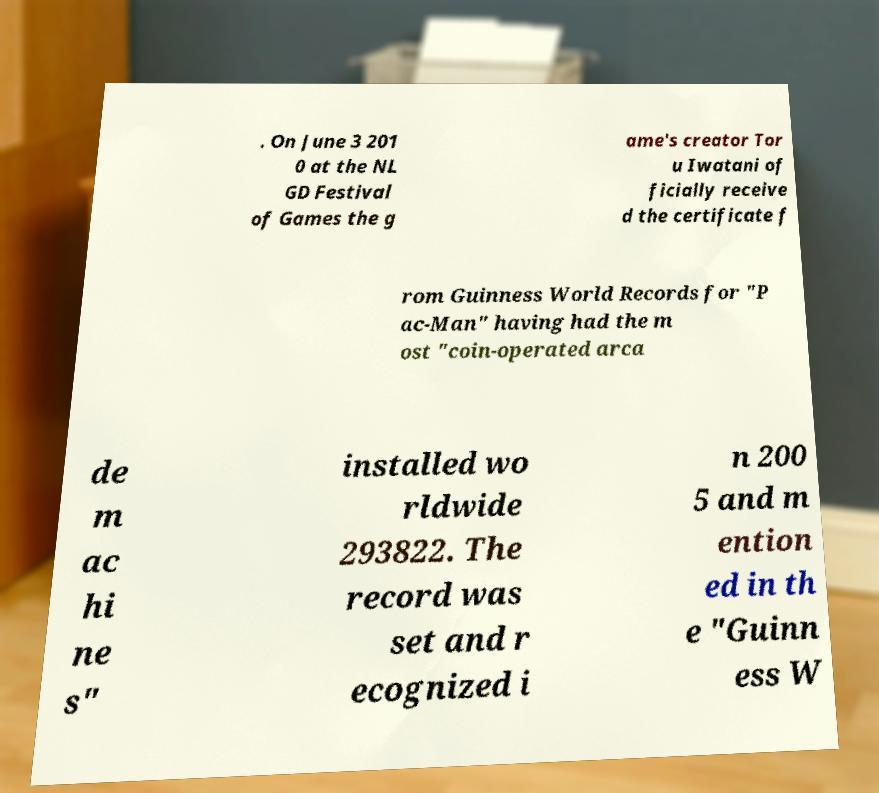For documentation purposes, I need the text within this image transcribed. Could you provide that? . On June 3 201 0 at the NL GD Festival of Games the g ame's creator Tor u Iwatani of ficially receive d the certificate f rom Guinness World Records for "P ac-Man" having had the m ost "coin-operated arca de m ac hi ne s" installed wo rldwide 293822. The record was set and r ecognized i n 200 5 and m ention ed in th e "Guinn ess W 